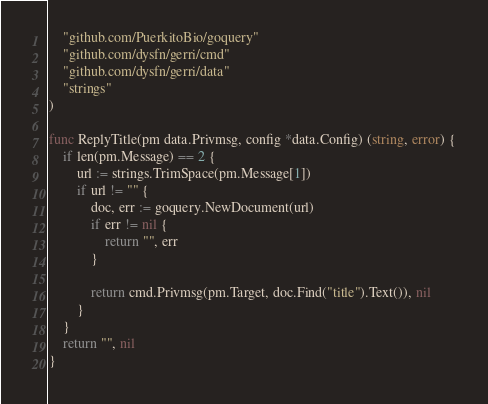Convert code to text. <code><loc_0><loc_0><loc_500><loc_500><_Go_>	"github.com/PuerkitoBio/goquery"
	"github.com/dysfn/gerri/cmd"
	"github.com/dysfn/gerri/data"
	"strings"
)

func ReplyTitle(pm data.Privmsg, config *data.Config) (string, error) {
	if len(pm.Message) == 2 {
		url := strings.TrimSpace(pm.Message[1])
		if url != "" {
			doc, err := goquery.NewDocument(url)
			if err != nil {
				return "", err
			}

			return cmd.Privmsg(pm.Target, doc.Find("title").Text()), nil
		}
	}
	return "", nil
}
</code> 